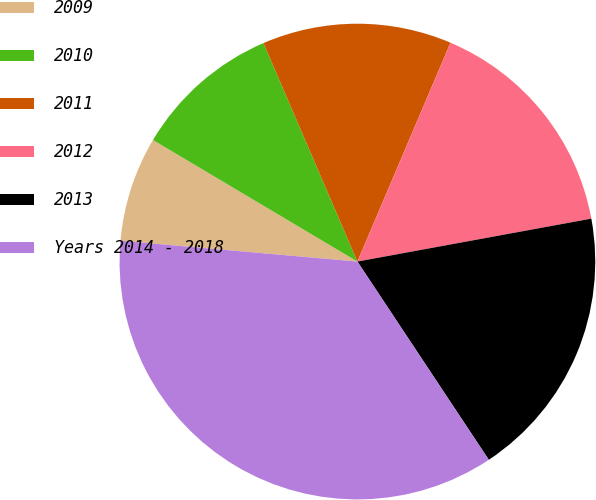Convert chart to OTSL. <chart><loc_0><loc_0><loc_500><loc_500><pie_chart><fcel>2009<fcel>2010<fcel>2011<fcel>2012<fcel>2013<fcel>Years 2014 - 2018<nl><fcel>7.14%<fcel>10.0%<fcel>12.86%<fcel>15.71%<fcel>18.57%<fcel>35.71%<nl></chart> 